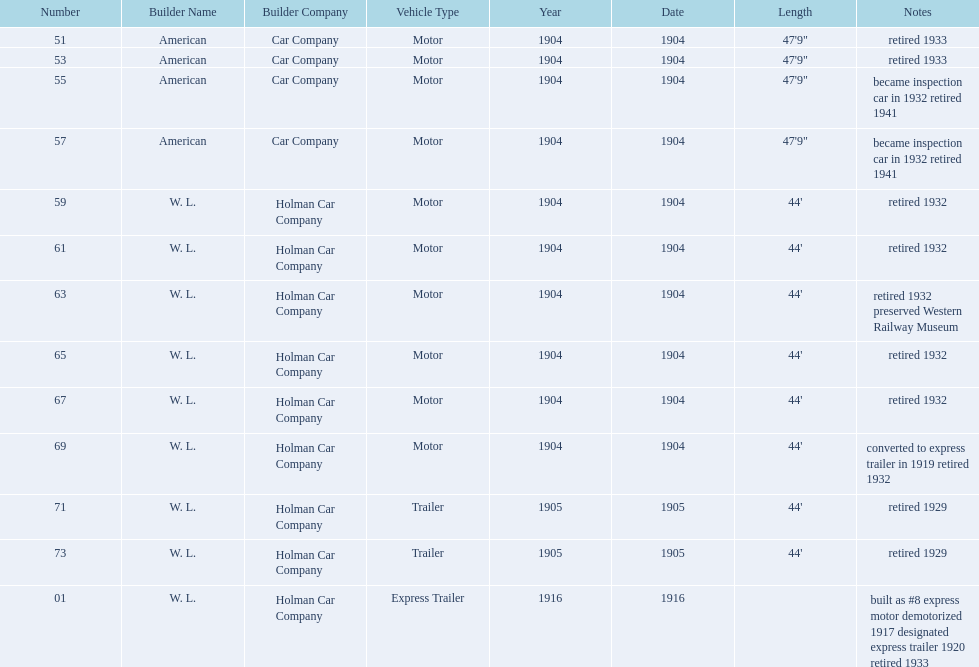In 1906, how many total rolling stock vehicles were in service? 12. 